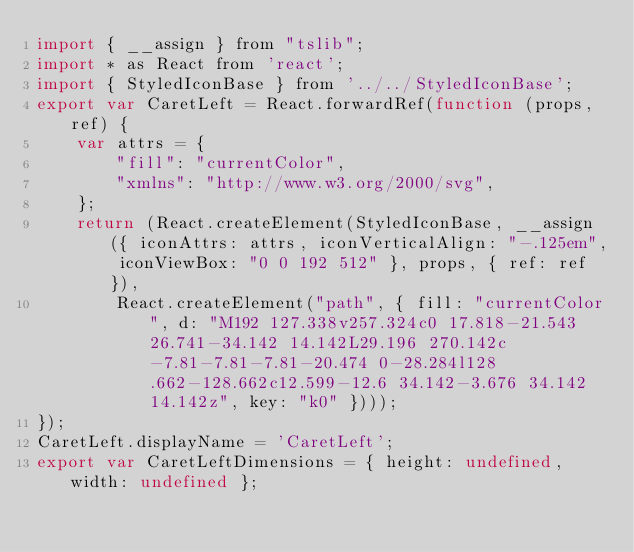<code> <loc_0><loc_0><loc_500><loc_500><_JavaScript_>import { __assign } from "tslib";
import * as React from 'react';
import { StyledIconBase } from '../../StyledIconBase';
export var CaretLeft = React.forwardRef(function (props, ref) {
    var attrs = {
        "fill": "currentColor",
        "xmlns": "http://www.w3.org/2000/svg",
    };
    return (React.createElement(StyledIconBase, __assign({ iconAttrs: attrs, iconVerticalAlign: "-.125em", iconViewBox: "0 0 192 512" }, props, { ref: ref }),
        React.createElement("path", { fill: "currentColor", d: "M192 127.338v257.324c0 17.818-21.543 26.741-34.142 14.142L29.196 270.142c-7.81-7.81-7.81-20.474 0-28.284l128.662-128.662c12.599-12.6 34.142-3.676 34.142 14.142z", key: "k0" })));
});
CaretLeft.displayName = 'CaretLeft';
export var CaretLeftDimensions = { height: undefined, width: undefined };
</code> 